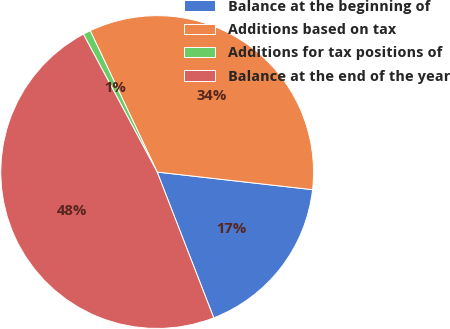Convert chart to OTSL. <chart><loc_0><loc_0><loc_500><loc_500><pie_chart><fcel>Balance at the beginning of<fcel>Additions based on tax<fcel>Additions for tax positions of<fcel>Balance at the end of the year<nl><fcel>17.31%<fcel>33.84%<fcel>0.78%<fcel>48.08%<nl></chart> 